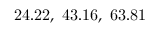<formula> <loc_0><loc_0><loc_500><loc_500>2 4 . 2 2 , 4 3 . 1 6 , 6 3 . 8 1</formula> 